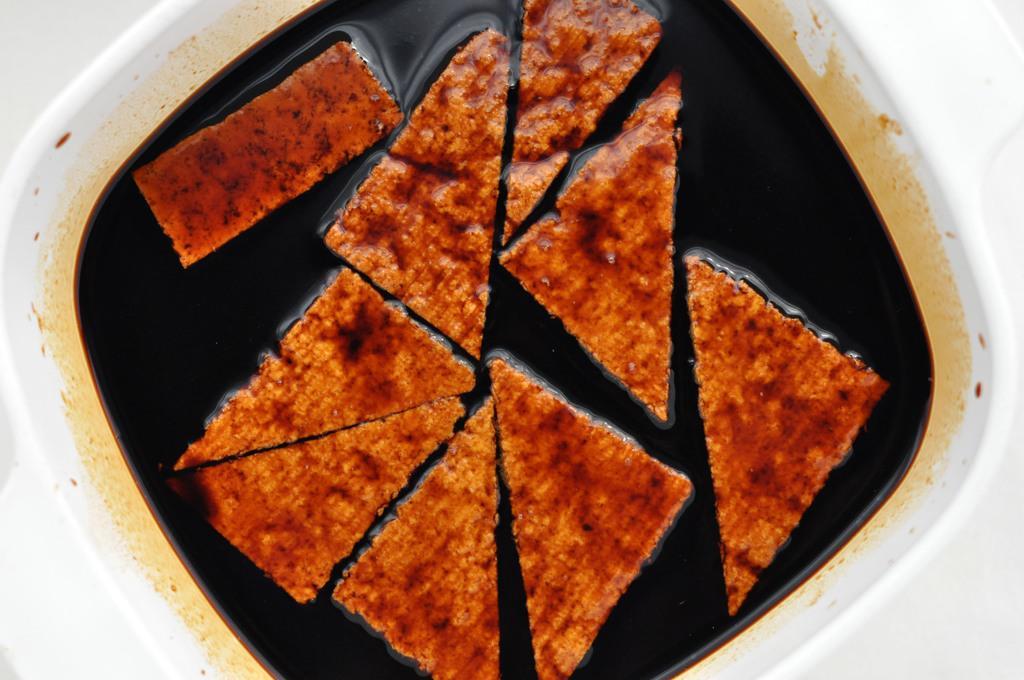Please provide a concise description of this image. In this picture we can see food and liquid in a bowl. 